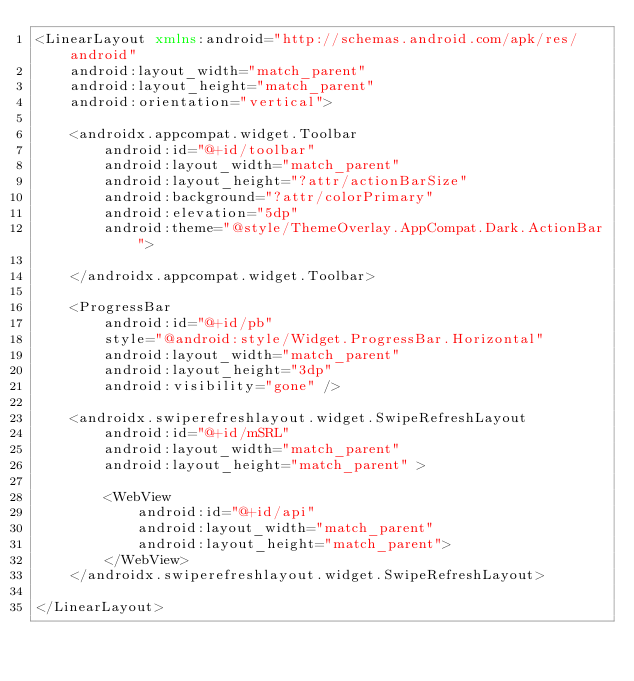Convert code to text. <code><loc_0><loc_0><loc_500><loc_500><_XML_><LinearLayout xmlns:android="http://schemas.android.com/apk/res/android"
    android:layout_width="match_parent"
    android:layout_height="match_parent"
    android:orientation="vertical">

    <androidx.appcompat.widget.Toolbar
        android:id="@+id/toolbar"
        android:layout_width="match_parent"
        android:layout_height="?attr/actionBarSize"
        android:background="?attr/colorPrimary"
        android:elevation="5dp"
        android:theme="@style/ThemeOverlay.AppCompat.Dark.ActionBar">

    </androidx.appcompat.widget.Toolbar>

    <ProgressBar
        android:id="@+id/pb"
        style="@android:style/Widget.ProgressBar.Horizontal"
        android:layout_width="match_parent"
        android:layout_height="3dp"
        android:visibility="gone" />

    <androidx.swiperefreshlayout.widget.SwipeRefreshLayout
        android:id="@+id/mSRL"
        android:layout_width="match_parent"
        android:layout_height="match_parent" >

        <WebView
            android:id="@+id/api"
            android:layout_width="match_parent"
            android:layout_height="match_parent">
        </WebView>
    </androidx.swiperefreshlayout.widget.SwipeRefreshLayout>

</LinearLayout></code> 